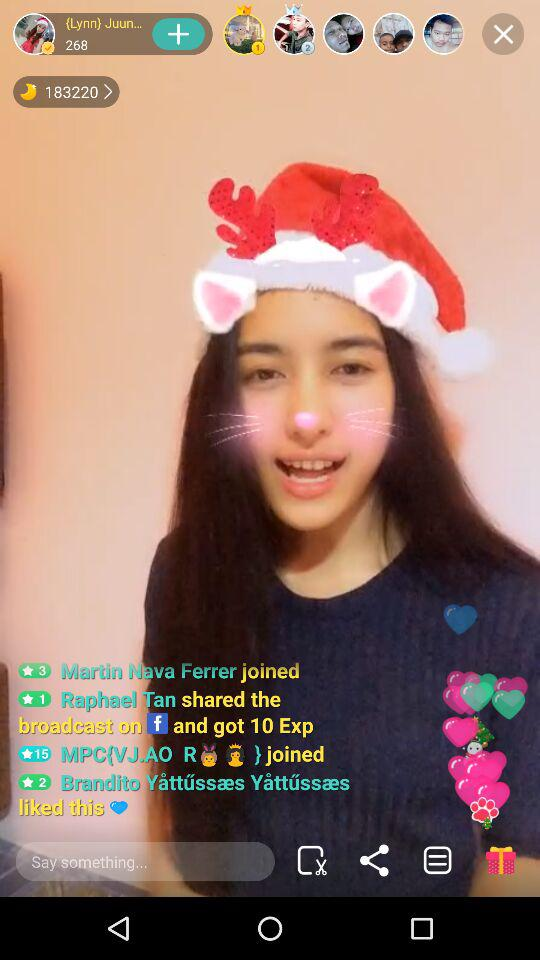How many Exp did the user get by sharing this broadcast on "Facebook"? The user got 10 Exp. 